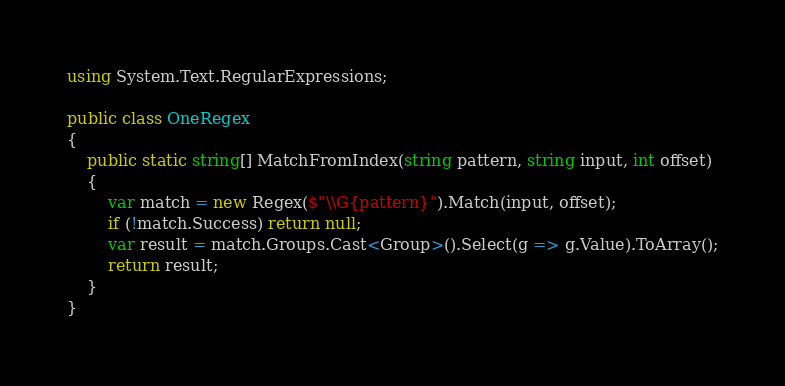Convert code to text. <code><loc_0><loc_0><loc_500><loc_500><_C#_>using System.Text.RegularExpressions;

public class OneRegex
{
    public static string[] MatchFromIndex(string pattern, string input, int offset)
    {
        var match = new Regex($"\\G{pattern}").Match(input, offset);
        if (!match.Success) return null;
        var result = match.Groups.Cast<Group>().Select(g => g.Value).ToArray();
        return result;
    }
}
</code> 